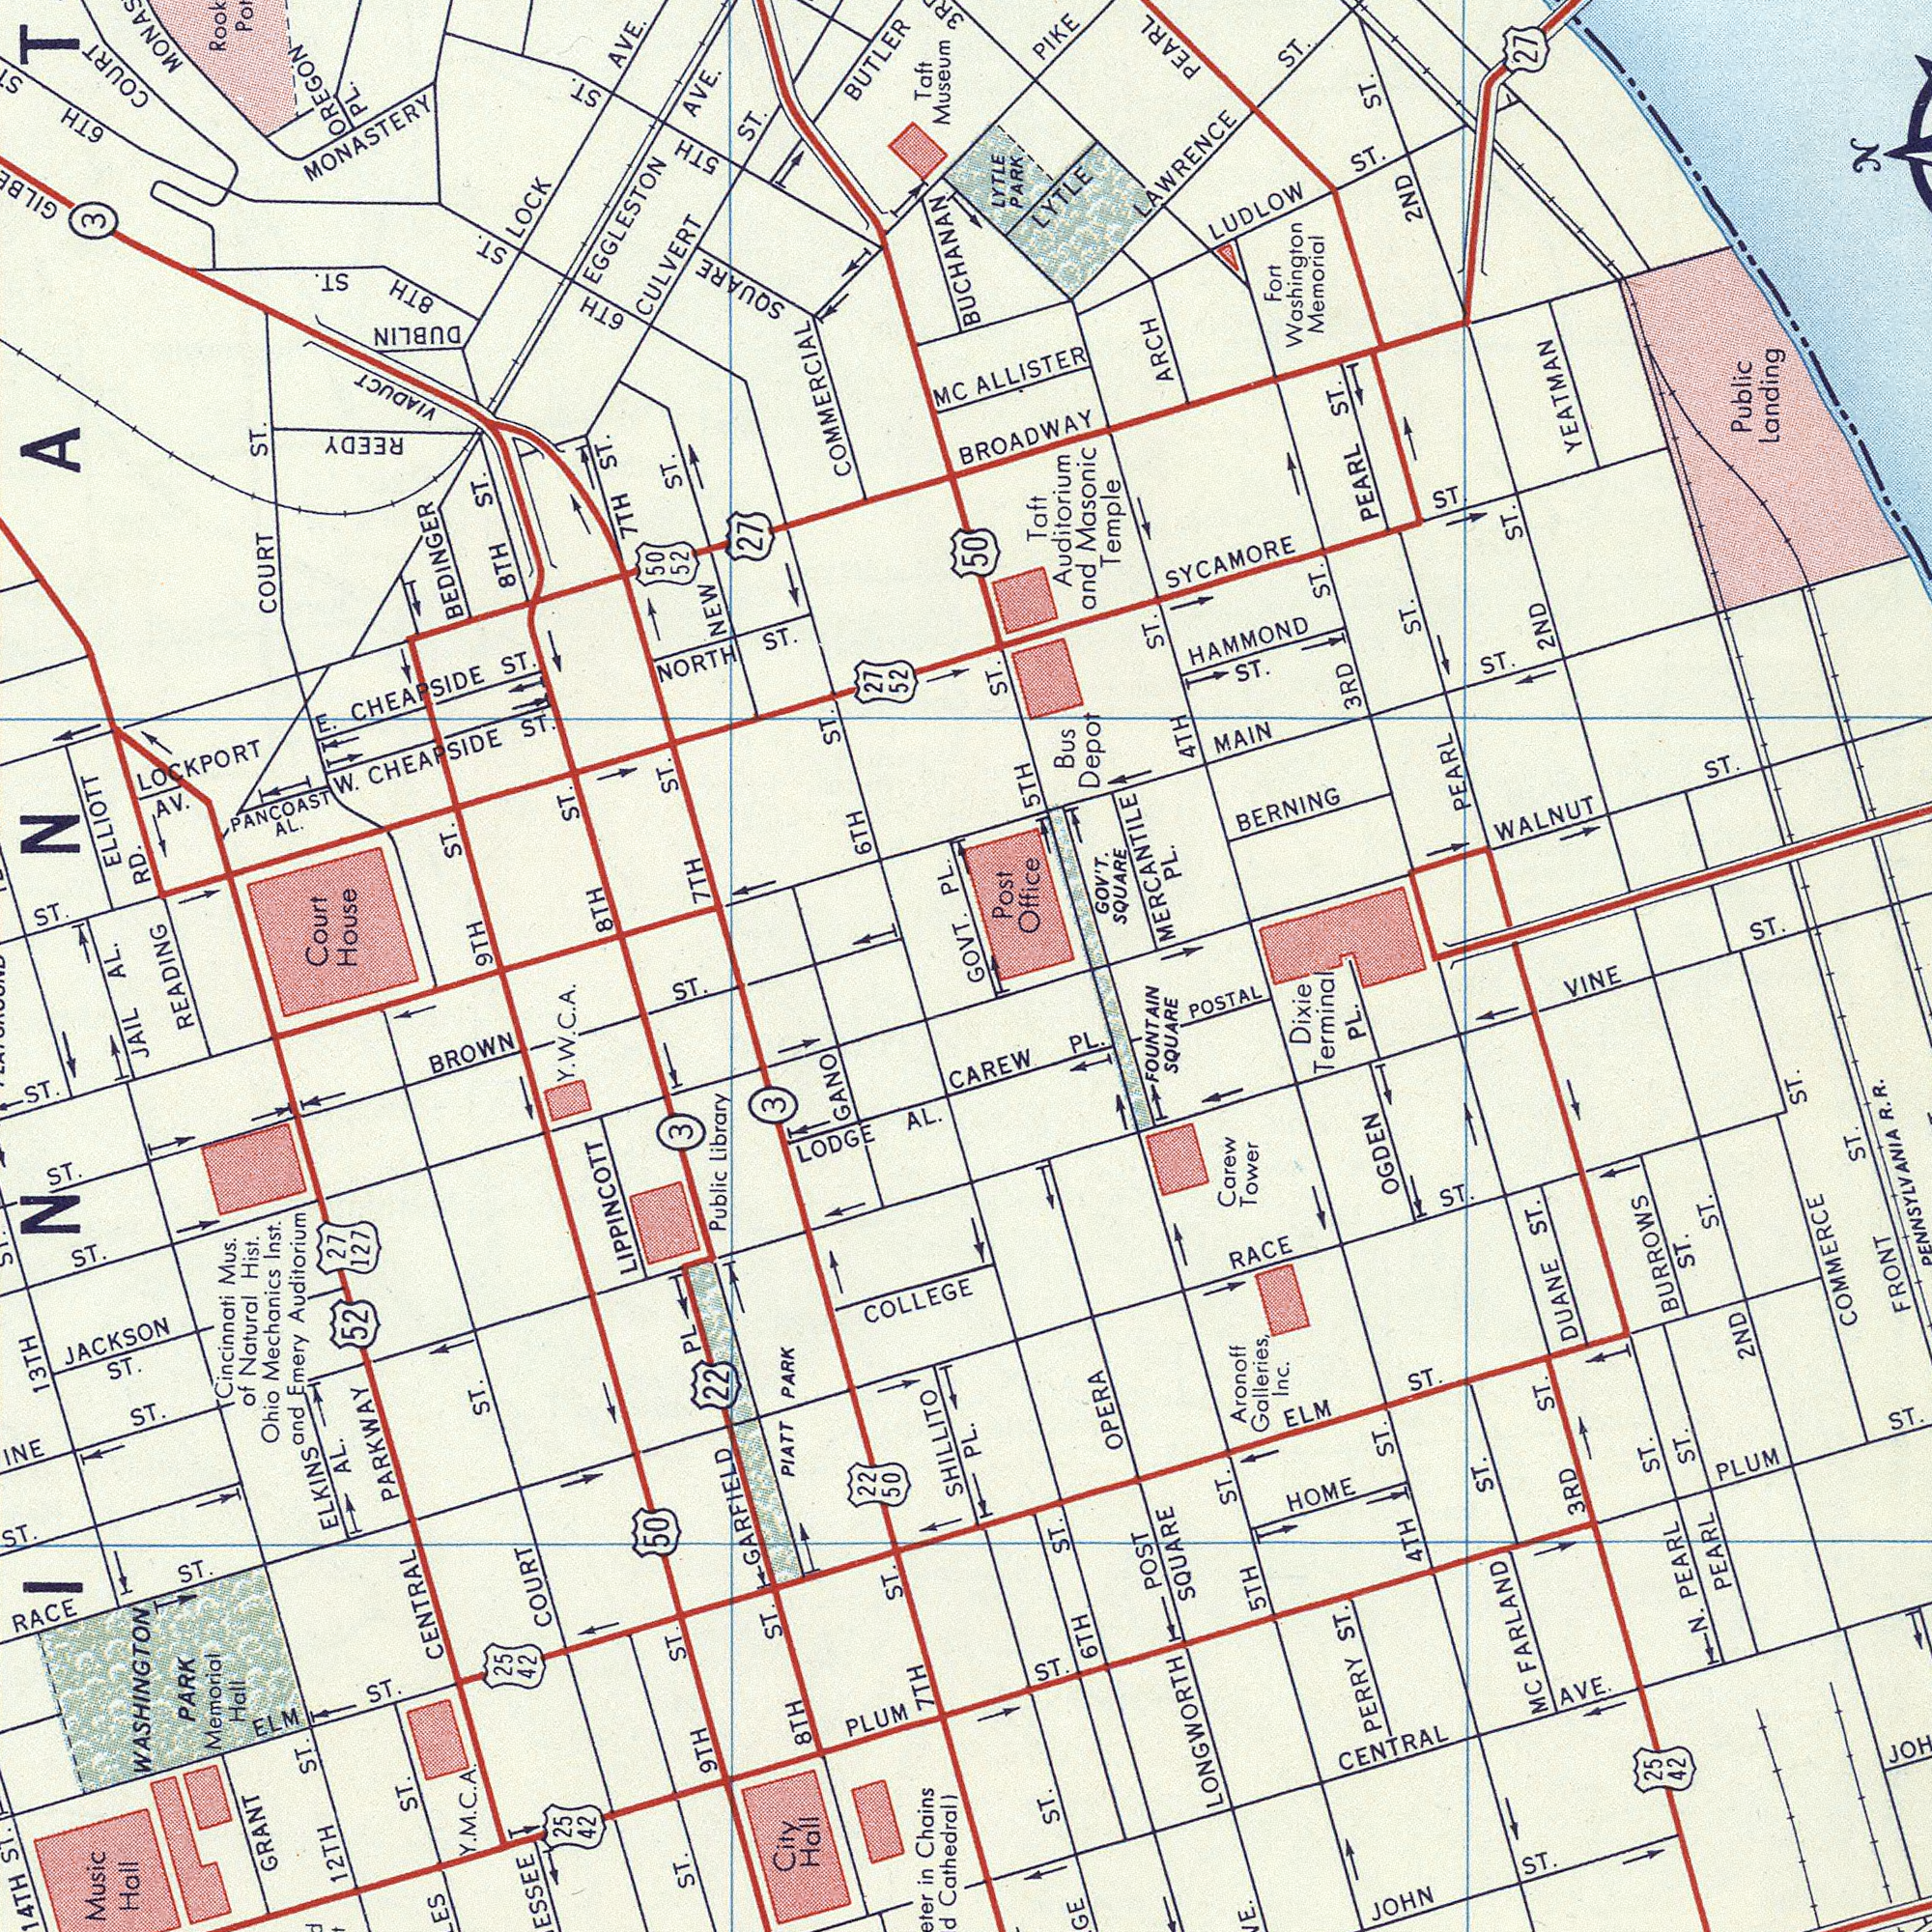What text is visible in the lower-left corner? READING in Chains Cathedral) CENTRAL PARKWAY LODGE AL. GRANT SHILLITO JACKSON ST. WASHINGTON PARK Memorial Hall ST. ST. ELM ST. Public Library BROWN ST. PIATT PARK ST. COLLEGE Music Hall 14TH ST. Cincinnati Mus. of Natural Hist. Ohio Mechanics lnst. and Emery Auditorim ST. COURT ST. RACE ST. ELKINA AL. ST. ST. 9TH ST. PLUM 7TH ST. JAIL 22 27 127 GANO 52 ST. GARFIEEDD PL City Hall LIPPINCOTT 12TH ST. 8TH ST. 50 13 TH 25 42 Y. M. C. A. 25 42 50 22 3 3 Y. W. C. A. What text is shown in the top-right quadrant? ALLISTER GOVT. SYCAMORE ST. LAWRENCE ST. BROOADWAY PEARL ST. LUDLOW ST. WALNUT ST. MORCANTILE PL. ST. Taft Auditorim and Masonic Temple 4TH ST. MAIN ST. 2ND ST. 3RD ST. 5TH ST. HAMMOND ST. Public landing LYTLE PIKE Post Office Fort Woshington Memorial ARCH Bus Depot YEATMAN LYTLE PARK GOVˈ̓T. SQUARE PEARL 2ND ST. PEARL ST. 27 N BERNING 50 What text appears in the bottom-right area of the image? VINE PL. ST. BURROWS ST. FRONT ST. PERRY ST. N. PEARL ST. Dixie Terminal ST. JOHN ST. MC FARLAND ST. PLUM ST. Carew Tower RACE ST. CAREW PL. POST SQUARE HOME POSTAL 2ND ST. ELM ST. CENTRAL AVE. Aronoff Galleries, Inc. PEARL ST. LONGWORTH DUANE ST. FOUNTAIN SQUARE 4TH ST. OGDEN PL. COMMERCE ST. 3RD ST. OPERA 5TH ST. R. R. 6TH ST. 25 42 What text is shown in the top-left quadrant? LOCKPORT AV. CULVERT ST. W. CHEAPSIDE ST. COURT ST. EGGLESTON AVE. RD. NORTH ST. ST. E. CHEAPSIDE ST. LOCK AVE. Court House 7TH ST. 8TH ST. BUTLER ELLIOTT 8TH ST. COMMERCIAL HaYnOS NEW ST. PANCOAST AL. COURT 6TH ST. BEDINGER 27 MC MONASTERY 9TH ST. PL. OREGON PL. 7TH ST. AL. 6TH ST. 5TH ST. 6TH 8TH ST. Taft Museum REEDY BUCHANAN ###INNAT### 3 VIADUCT DUBLIN 50 52 27 52 